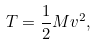<formula> <loc_0><loc_0><loc_500><loc_500>T = \frac { 1 } { 2 } M { v ^ { 2 } } ,</formula> 